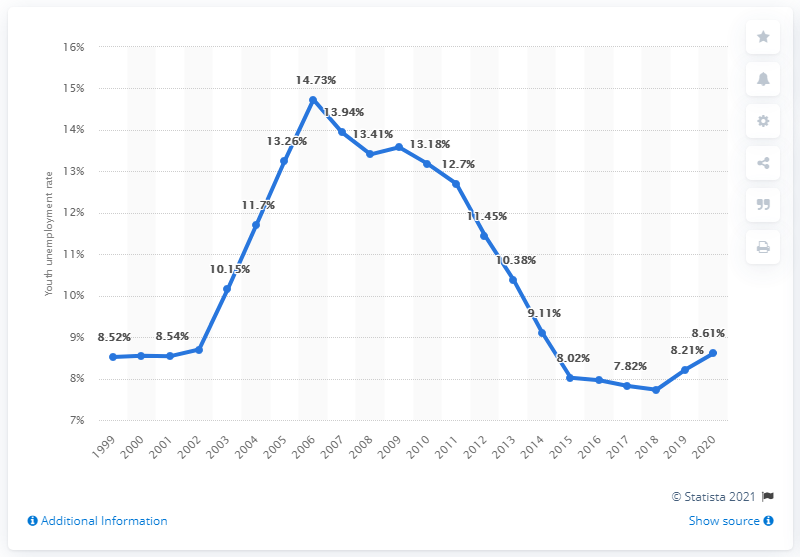Identify some key points in this picture. In 2020, the youth unemployment rate in Senegal was 8.61%. 